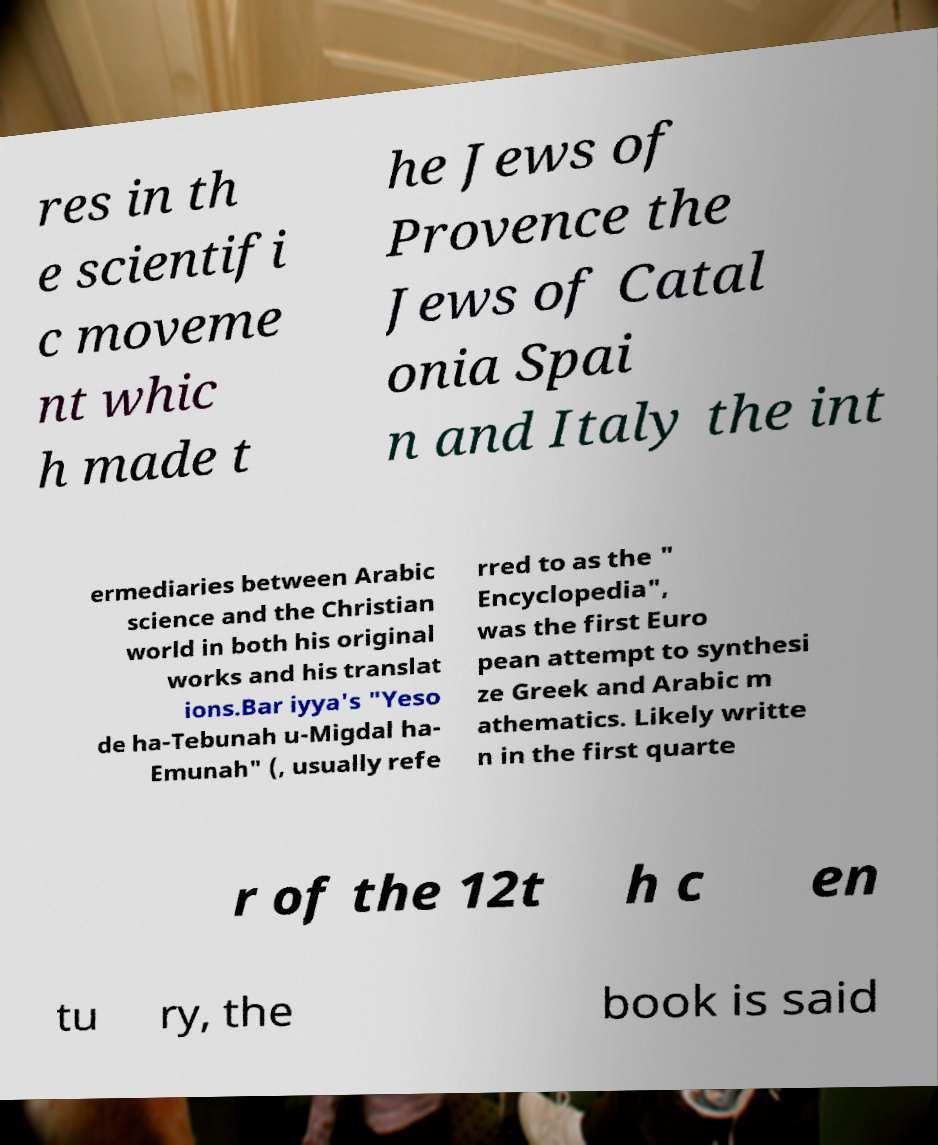There's text embedded in this image that I need extracted. Can you transcribe it verbatim? res in th e scientifi c moveme nt whic h made t he Jews of Provence the Jews of Catal onia Spai n and Italy the int ermediaries between Arabic science and the Christian world in both his original works and his translat ions.Bar iyya's "Yeso de ha-Tebunah u-Migdal ha- Emunah" (, usually refe rred to as the " Encyclopedia", was the first Euro pean attempt to synthesi ze Greek and Arabic m athematics. Likely writte n in the first quarte r of the 12t h c en tu ry, the book is said 